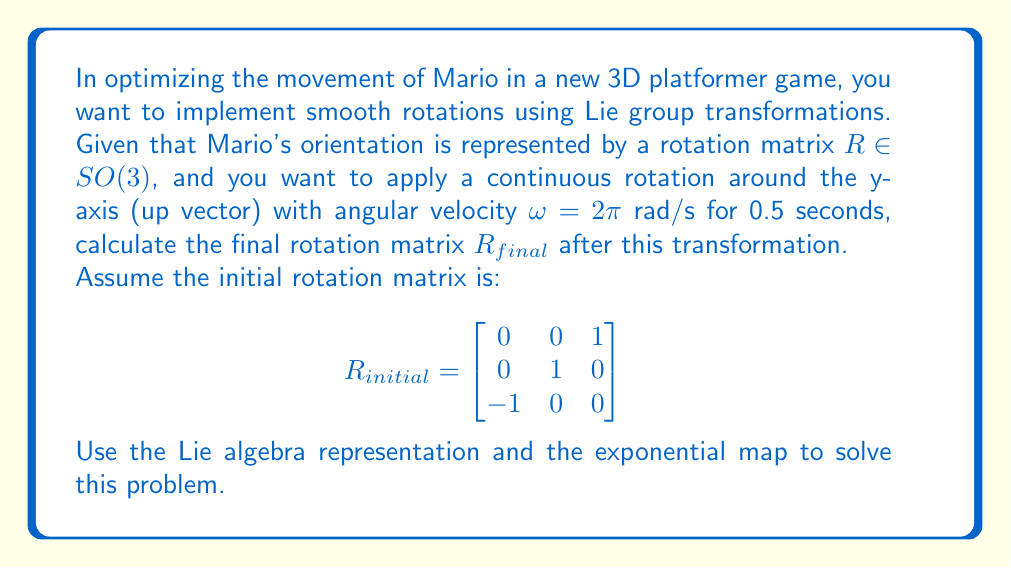Can you answer this question? To solve this problem, we'll follow these steps:

1) First, we need to identify the Lie algebra element corresponding to rotation around the y-axis. In $\mathfrak{so}(3)$, this is represented by:

   $$\omega_y = \begin{bmatrix}
   0 & 0 & 1 \\
   0 & 0 & 0 \\
   -1 & 0 & 0
   \end{bmatrix}$$

2) The total rotation angle is $\theta = \omega t = 2\pi \cdot 0.5 = \pi$ rad.

3) The Lie algebra element for our transformation is:

   $$X = \theta \omega_y = \pi \begin{bmatrix}
   0 & 0 & 1 \\
   0 & 0 & 0 \\
   -1 & 0 & 0
   \end{bmatrix}$$

4) We can compute the exponential map using Rodrigues' formula:

   $$\exp(X) = I + \sin(\theta)X^{\vee} + (1-\cos(\theta))(X^{\vee})^2$$

   where $X^{\vee}$ is the normalized skew-symmetric matrix.

5) In this case:

   $$\exp(X) = I + \sin(\pi)\begin{bmatrix}
   0 & 0 & 1 \\
   0 & 0 & 0 \\
   -1 & 0 & 0
   \end{bmatrix} + (1-\cos(\pi))\begin{bmatrix}
   -1 & 0 & 0 \\
   0 & 0 & 0 \\
   0 & 0 & -1
   \end{bmatrix}$$

6) Simplifying:

   $$\exp(X) = \begin{bmatrix}
   -1 & 0 & 0 \\
   0 & 1 & 0 \\
   0 & 0 & -1
   \end{bmatrix}$$

7) The final rotation is obtained by multiplying the initial rotation with this transformation:

   $$R_{final} = R_{initial} \cdot \exp(X)$$

8) Performing the matrix multiplication:

   $$R_{final} = \begin{bmatrix}
   0 & 0 & 1 \\
   0 & 1 & 0 \\
   -1 & 0 & 0
   \end{bmatrix} \cdot \begin{bmatrix}
   -1 & 0 & 0 \\
   0 & 1 & 0 \\
   0 & 0 & -1
   \end{bmatrix} = \begin{bmatrix}
   0 & 0 & -1 \\
   0 & 1 & 0 \\
   -1 & 0 & 0
   \end{bmatrix}$$
Answer: The final rotation matrix after applying the transformation is:

$$R_{final} = \begin{bmatrix}
0 & 0 & -1 \\
0 & 1 & 0 \\
-1 & 0 & 0
\end{bmatrix}$$ 